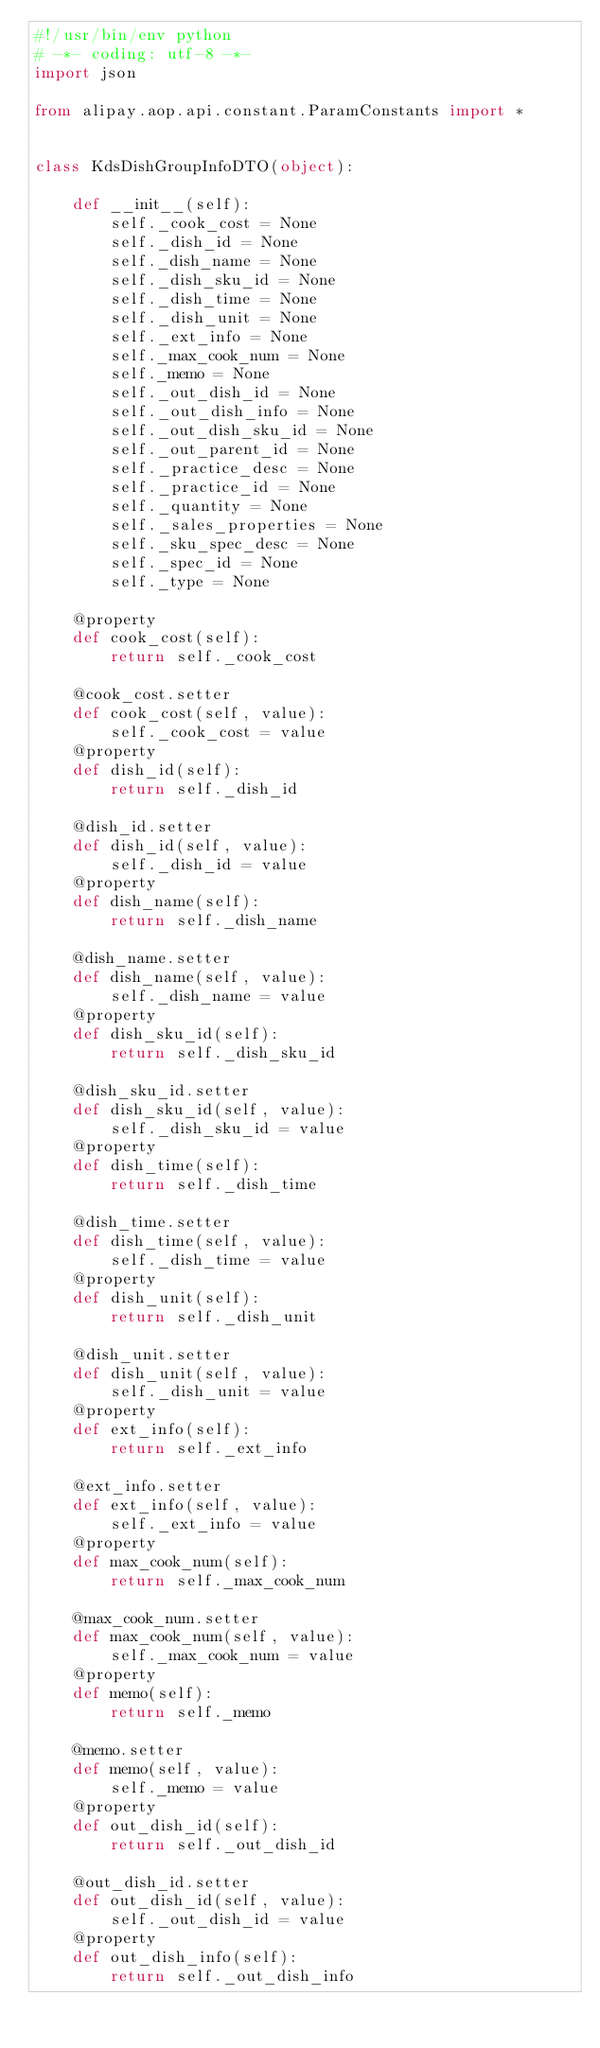<code> <loc_0><loc_0><loc_500><loc_500><_Python_>#!/usr/bin/env python
# -*- coding: utf-8 -*-
import json

from alipay.aop.api.constant.ParamConstants import *


class KdsDishGroupInfoDTO(object):

    def __init__(self):
        self._cook_cost = None
        self._dish_id = None
        self._dish_name = None
        self._dish_sku_id = None
        self._dish_time = None
        self._dish_unit = None
        self._ext_info = None
        self._max_cook_num = None
        self._memo = None
        self._out_dish_id = None
        self._out_dish_info = None
        self._out_dish_sku_id = None
        self._out_parent_id = None
        self._practice_desc = None
        self._practice_id = None
        self._quantity = None
        self._sales_properties = None
        self._sku_spec_desc = None
        self._spec_id = None
        self._type = None

    @property
    def cook_cost(self):
        return self._cook_cost

    @cook_cost.setter
    def cook_cost(self, value):
        self._cook_cost = value
    @property
    def dish_id(self):
        return self._dish_id

    @dish_id.setter
    def dish_id(self, value):
        self._dish_id = value
    @property
    def dish_name(self):
        return self._dish_name

    @dish_name.setter
    def dish_name(self, value):
        self._dish_name = value
    @property
    def dish_sku_id(self):
        return self._dish_sku_id

    @dish_sku_id.setter
    def dish_sku_id(self, value):
        self._dish_sku_id = value
    @property
    def dish_time(self):
        return self._dish_time

    @dish_time.setter
    def dish_time(self, value):
        self._dish_time = value
    @property
    def dish_unit(self):
        return self._dish_unit

    @dish_unit.setter
    def dish_unit(self, value):
        self._dish_unit = value
    @property
    def ext_info(self):
        return self._ext_info

    @ext_info.setter
    def ext_info(self, value):
        self._ext_info = value
    @property
    def max_cook_num(self):
        return self._max_cook_num

    @max_cook_num.setter
    def max_cook_num(self, value):
        self._max_cook_num = value
    @property
    def memo(self):
        return self._memo

    @memo.setter
    def memo(self, value):
        self._memo = value
    @property
    def out_dish_id(self):
        return self._out_dish_id

    @out_dish_id.setter
    def out_dish_id(self, value):
        self._out_dish_id = value
    @property
    def out_dish_info(self):
        return self._out_dish_info
</code> 